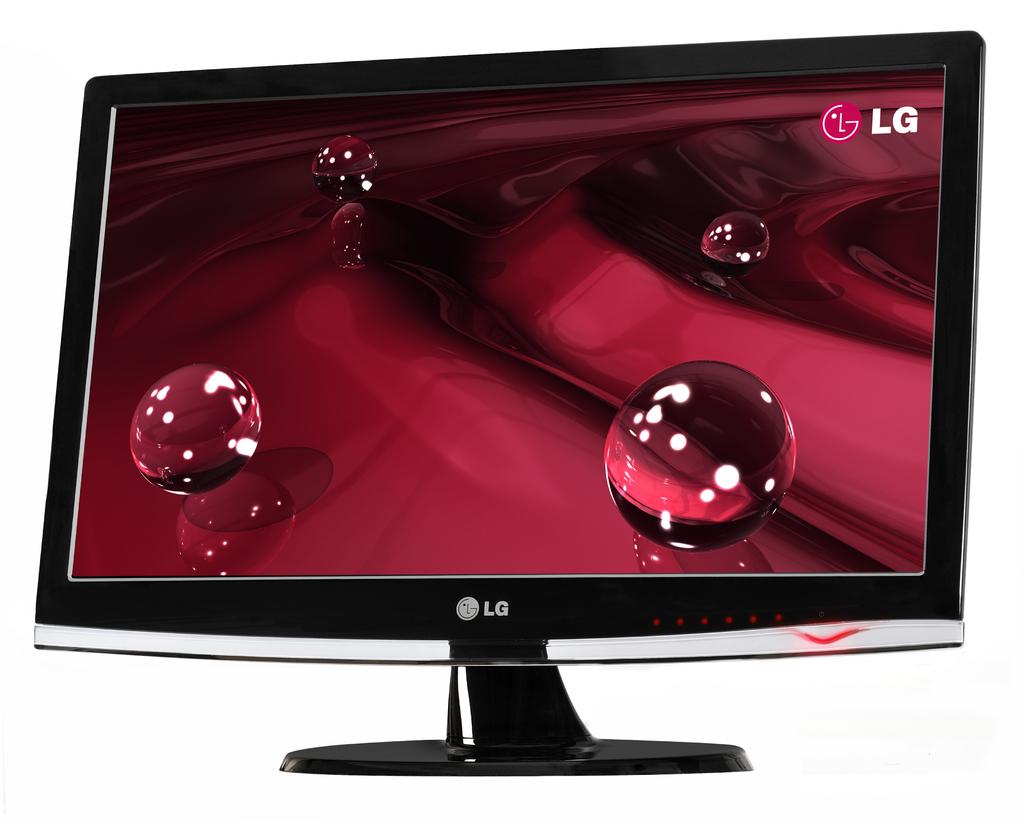What brand of monitor is this?
Ensure brevity in your answer.  Lg. 